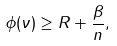<formula> <loc_0><loc_0><loc_500><loc_500>\phi ( \nu ) \geq R + \frac { \beta } { n } ,</formula> 